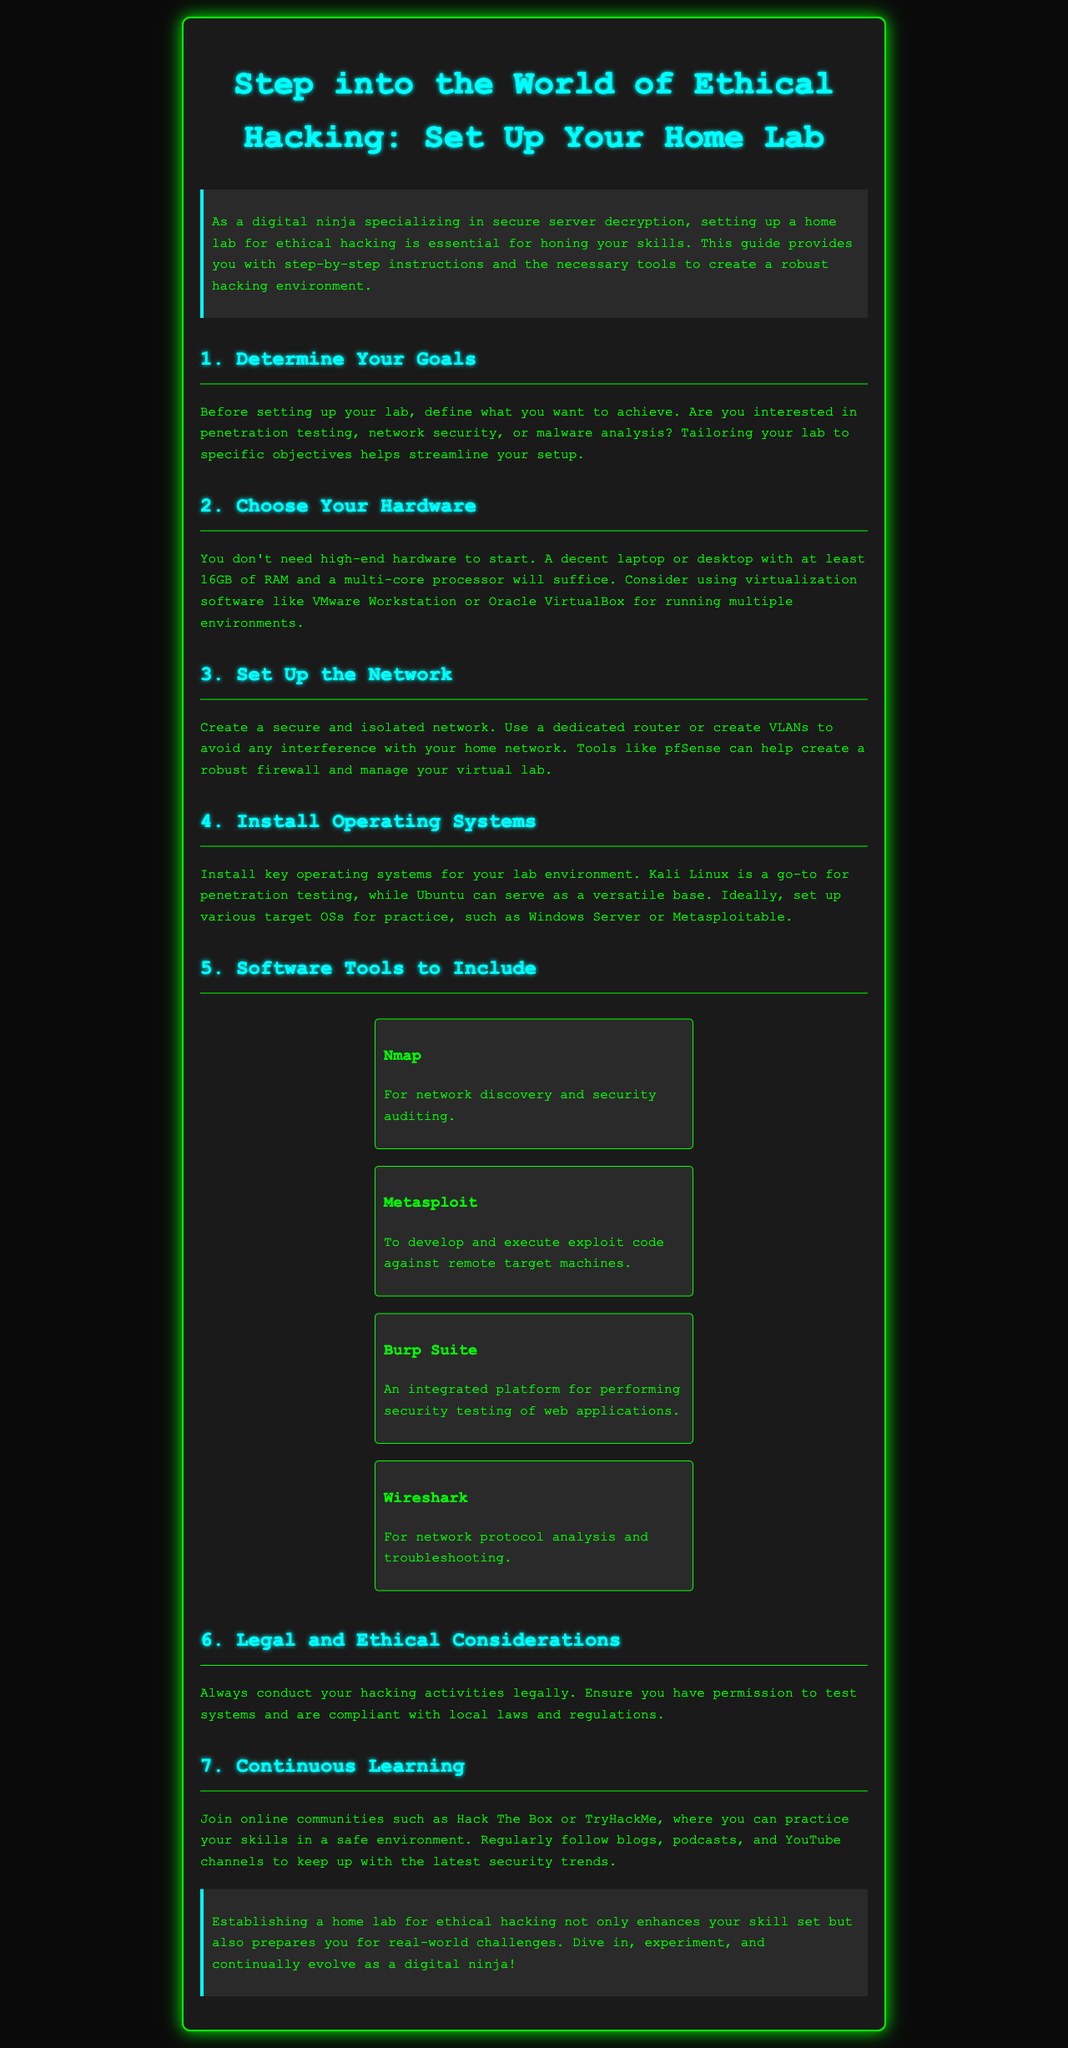What is the title of the document? The title is prominently displayed at the top of the document, indicating the focus of the content.
Answer: Step into the World of Ethical Hacking: Set Up Your Home Lab What is the minimum RAM recommended for setting up your hardware? The document specifies a requirement for hardware to ensure adequate performance in the home lab setup.
Answer: 16GB Which operating system is mentioned as a go-to for penetration testing? The document lists specific operating systems that are essential for ethical hacking and identifies one for penetration testing.
Answer: Kali Linux How many software tools are highlighted in the section about software tools? The document lists a total number of tools useful for ethical hacking.
Answer: 4 What should you always ensure before conducting hacking activities? The document emphasizes the importance of legality in conducting ethical hacking practices.
Answer: Permission What online communities are suggested for continuous learning? The document encourages engagement with certain platforms for practice and learning in ethical hacking.
Answer: Hack The Box or TryHackMe What is the main purpose of setting up a home lab according to the conclusion? The conclusion summarizes the benefit of creating a home lab based on the content discussed in the document.
Answer: Enhance skill set What should be tailored to specific objectives when setting up the lab? The document discusses the importance of focusing specific elements to streamline the setup process.
Answer: Goals 